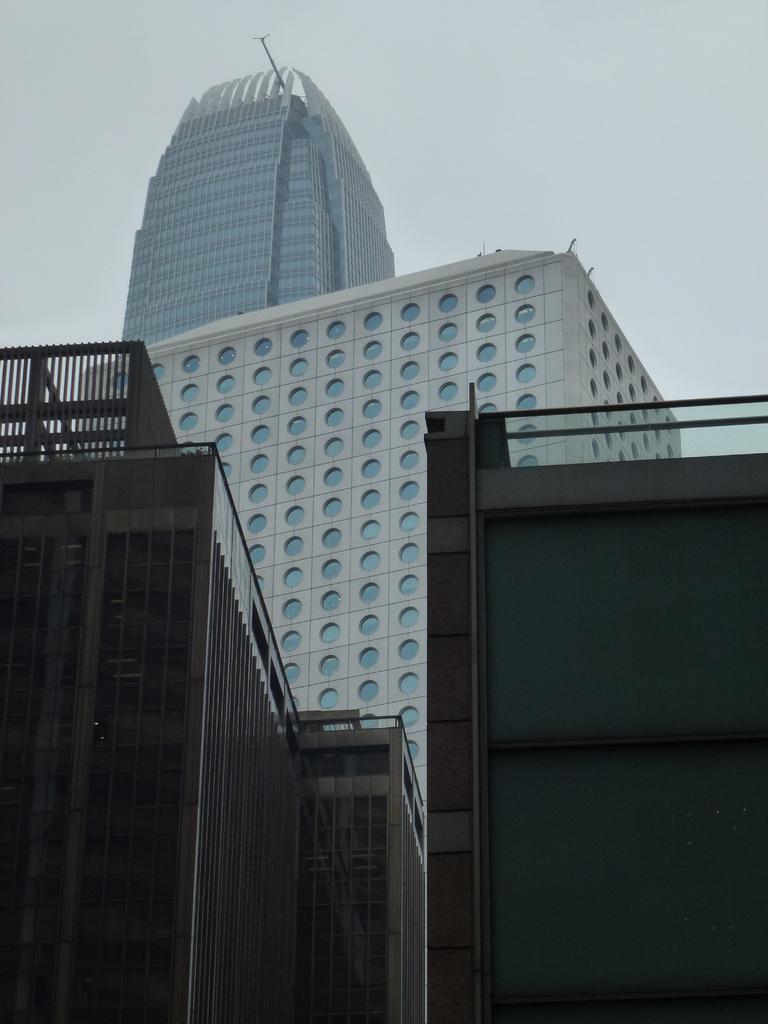Please provide a concise description of this image. In this picture I see number of buildings in front. In the background I see the sky. 